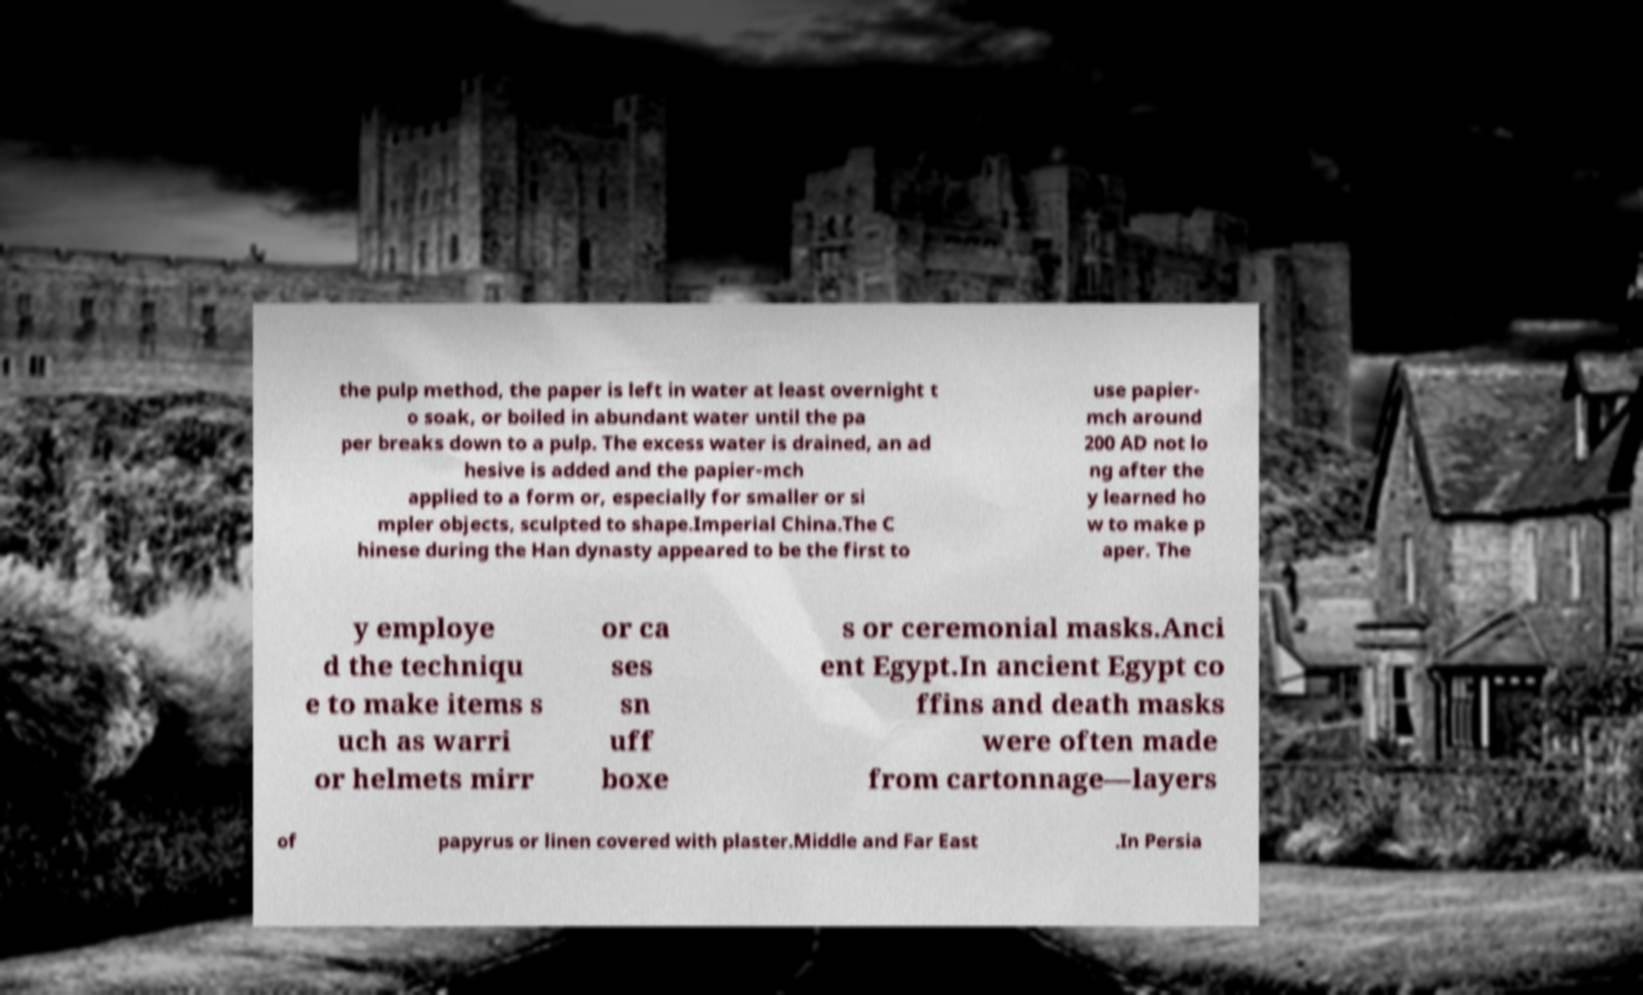For documentation purposes, I need the text within this image transcribed. Could you provide that? the pulp method, the paper is left in water at least overnight t o soak, or boiled in abundant water until the pa per breaks down to a pulp. The excess water is drained, an ad hesive is added and the papier-mch applied to a form or, especially for smaller or si mpler objects, sculpted to shape.Imperial China.The C hinese during the Han dynasty appeared to be the first to use papier- mch around 200 AD not lo ng after the y learned ho w to make p aper. The y employe d the techniqu e to make items s uch as warri or helmets mirr or ca ses sn uff boxe s or ceremonial masks.Anci ent Egypt.In ancient Egypt co ffins and death masks were often made from cartonnage—layers of papyrus or linen covered with plaster.Middle and Far East .In Persia 